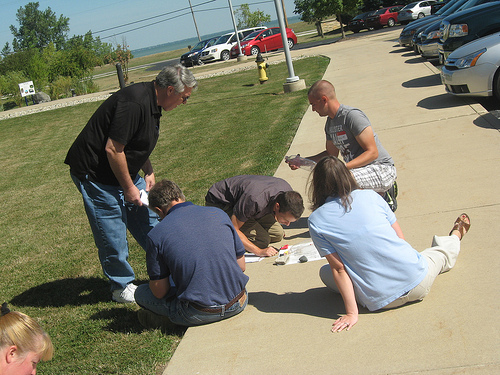<image>
Is the man above the rock? Yes. The man is positioned above the rock in the vertical space, higher up in the scene. 